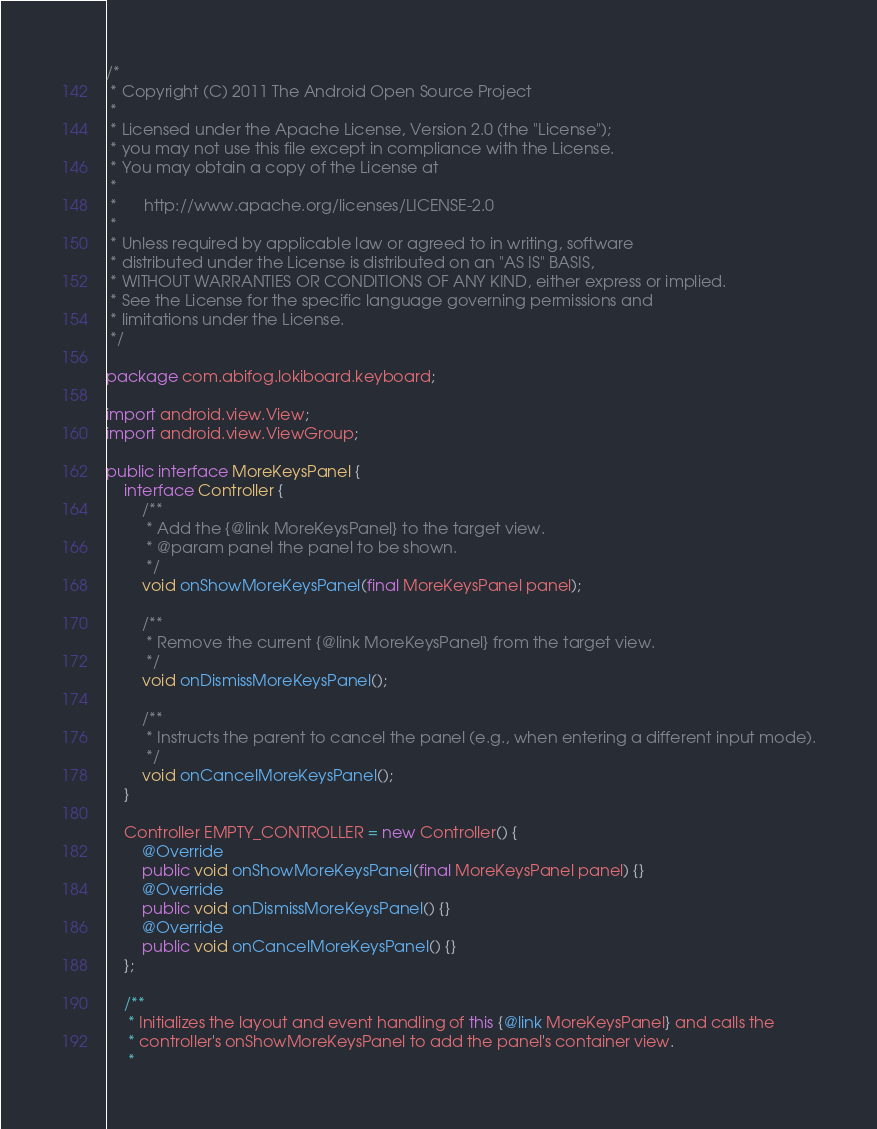<code> <loc_0><loc_0><loc_500><loc_500><_Java_>/*
 * Copyright (C) 2011 The Android Open Source Project
 *
 * Licensed under the Apache License, Version 2.0 (the "License");
 * you may not use this file except in compliance with the License.
 * You may obtain a copy of the License at
 *
 *      http://www.apache.org/licenses/LICENSE-2.0
 *
 * Unless required by applicable law or agreed to in writing, software
 * distributed under the License is distributed on an "AS IS" BASIS,
 * WITHOUT WARRANTIES OR CONDITIONS OF ANY KIND, either express or implied.
 * See the License for the specific language governing permissions and
 * limitations under the License.
 */

package com.abifog.lokiboard.keyboard;

import android.view.View;
import android.view.ViewGroup;

public interface MoreKeysPanel {
    interface Controller {
        /**
         * Add the {@link MoreKeysPanel} to the target view.
         * @param panel the panel to be shown.
         */
        void onShowMoreKeysPanel(final MoreKeysPanel panel);

        /**
         * Remove the current {@link MoreKeysPanel} from the target view.
         */
        void onDismissMoreKeysPanel();

        /**
         * Instructs the parent to cancel the panel (e.g., when entering a different input mode).
         */
        void onCancelMoreKeysPanel();
    }

    Controller EMPTY_CONTROLLER = new Controller() {
        @Override
        public void onShowMoreKeysPanel(final MoreKeysPanel panel) {}
        @Override
        public void onDismissMoreKeysPanel() {}
        @Override
        public void onCancelMoreKeysPanel() {}
    };

    /**
     * Initializes the layout and event handling of this {@link MoreKeysPanel} and calls the
     * controller's onShowMoreKeysPanel to add the panel's container view.
     *</code> 